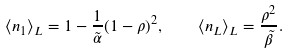Convert formula to latex. <formula><loc_0><loc_0><loc_500><loc_500>\langle n _ { 1 } \rangle _ { L } = 1 - \frac { 1 } { \tilde { \alpha } } ( 1 - \rho ) ^ { 2 } , \quad \langle n _ { L } \rangle _ { L } = \frac { \rho ^ { 2 } } { \tilde { \beta } } .</formula> 